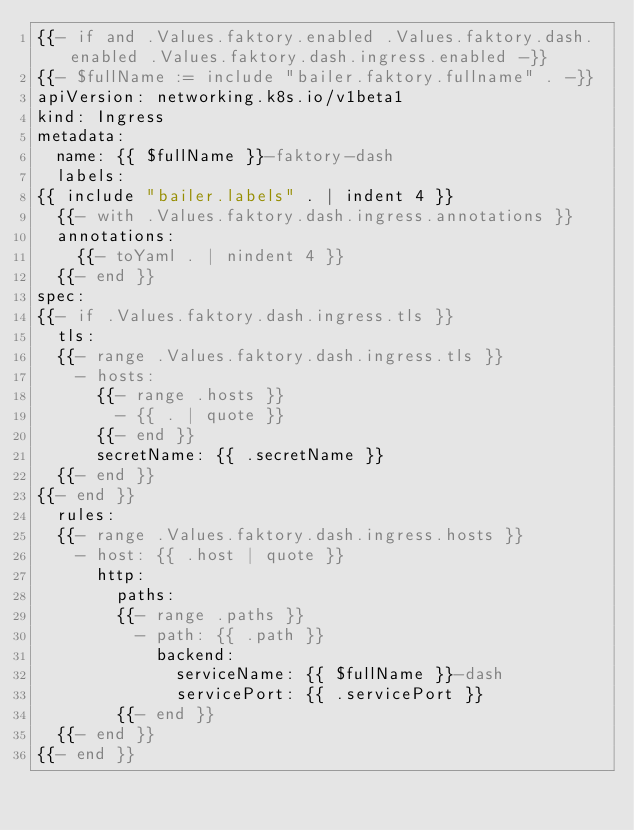Convert code to text. <code><loc_0><loc_0><loc_500><loc_500><_YAML_>{{- if and .Values.faktory.enabled .Values.faktory.dash.enabled .Values.faktory.dash.ingress.enabled -}}
{{- $fullName := include "bailer.faktory.fullname" . -}}
apiVersion: networking.k8s.io/v1beta1
kind: Ingress
metadata:
  name: {{ $fullName }}-faktory-dash
  labels:
{{ include "bailer.labels" . | indent 4 }}
  {{- with .Values.faktory.dash.ingress.annotations }}
  annotations:
    {{- toYaml . | nindent 4 }}
  {{- end }}
spec:
{{- if .Values.faktory.dash.ingress.tls }}
  tls:
  {{- range .Values.faktory.dash.ingress.tls }}
    - hosts:
      {{- range .hosts }}
        - {{ . | quote }}
      {{- end }}
      secretName: {{ .secretName }}
  {{- end }}
{{- end }}
  rules:
  {{- range .Values.faktory.dash.ingress.hosts }}
    - host: {{ .host | quote }}
      http:
        paths:
        {{- range .paths }}
          - path: {{ .path }}
            backend:
              serviceName: {{ $fullName }}-dash
              servicePort: {{ .servicePort }}
        {{- end }}
  {{- end }}
{{- end }}
</code> 